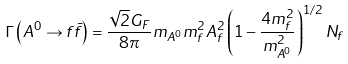<formula> <loc_0><loc_0><loc_500><loc_500>\Gamma \left ( A ^ { 0 } \rightarrow f \bar { f } \right ) = \frac { \sqrt { 2 } G _ { F } } { 8 \pi } m _ { A ^ { 0 } } m _ { f } ^ { 2 } A _ { f } ^ { 2 } \left ( 1 - \frac { 4 m _ { f } ^ { 2 } } { m _ { A ^ { 0 } } ^ { 2 } } \right ) ^ { 1 / 2 } N _ { f }</formula> 